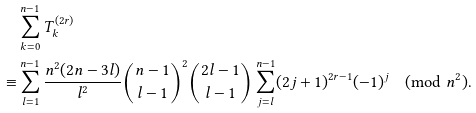Convert formula to latex. <formula><loc_0><loc_0><loc_500><loc_500>& \sum _ { k = 0 } ^ { n - 1 } T _ { k } ^ { ( 2 r ) } \\ \equiv & \sum _ { l = 1 } ^ { n - 1 } \frac { n ^ { 2 } ( 2 n - 3 l ) } { l ^ { 2 } } \binom { n - 1 } { l - 1 } ^ { 2 } \binom { 2 l - 1 } { l - 1 } \sum _ { j = l } ^ { n - 1 } ( 2 j + 1 ) ^ { 2 r - 1 } ( - 1 ) ^ { j } \pmod { n ^ { 2 } } .</formula> 